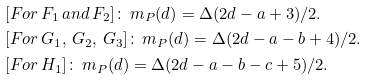Convert formula to latex. <formula><loc_0><loc_0><loc_500><loc_500>& [ F o r \, F _ { 1 } \, a n d \, F _ { 2 } ] \colon \, m _ { P } ( d ) = \Delta ( 2 d - a + 3 ) / 2 . \\ & [ F o r \, G _ { 1 } , \, G _ { 2 } , \, G _ { 3 } ] \colon \, m _ { P } ( d ) = \Delta ( 2 d - a - b + 4 ) / 2 . \\ & [ F o r \, H _ { 1 } ] \colon \, m _ { P } ( d ) = \Delta ( 2 d - a - b - c + 5 ) / 2 .</formula> 